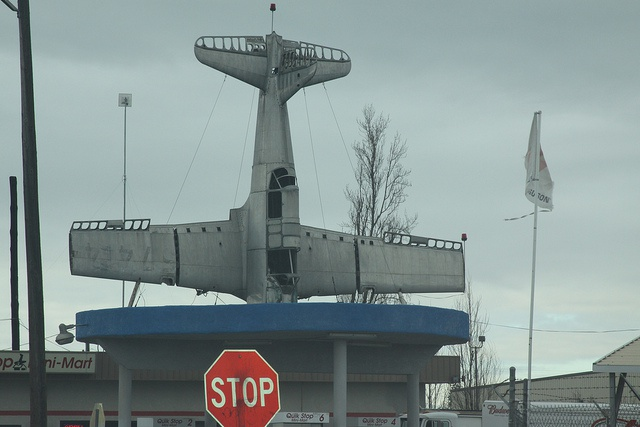Describe the objects in this image and their specific colors. I can see airplane in darkgray, gray, black, and purple tones and stop sign in darkgray, brown, and beige tones in this image. 